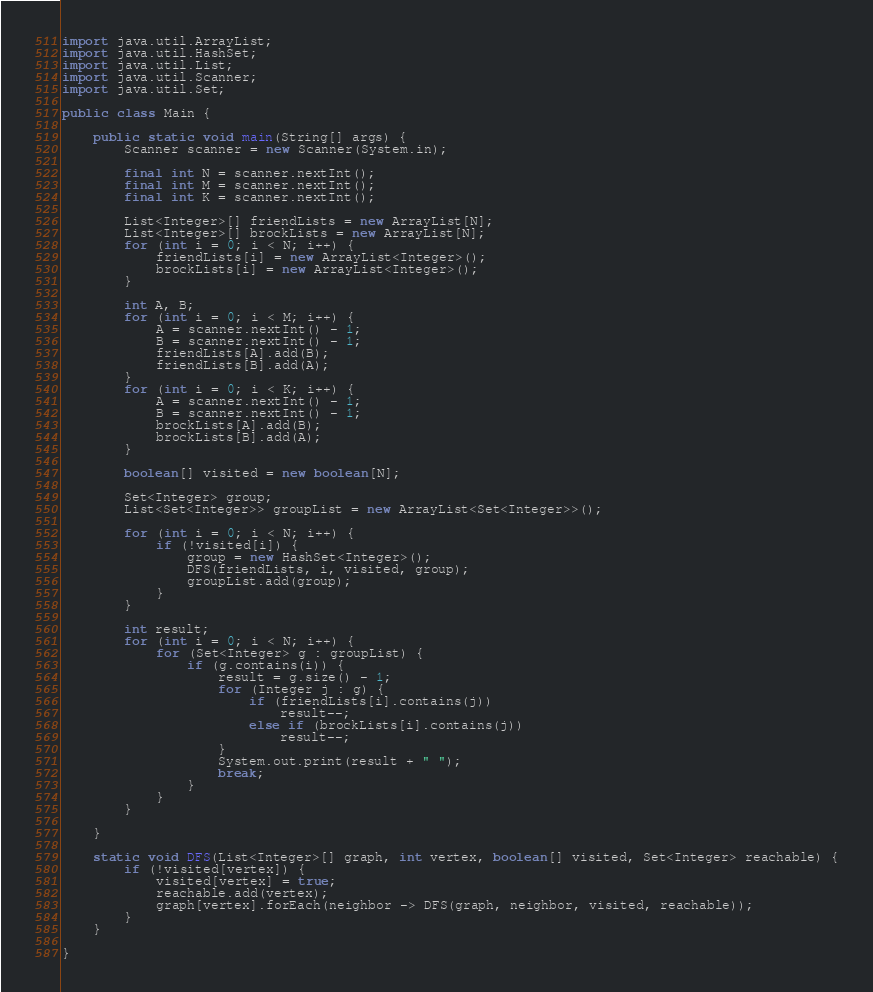<code> <loc_0><loc_0><loc_500><loc_500><_Java_>import java.util.ArrayList;
import java.util.HashSet;
import java.util.List;
import java.util.Scanner;
import java.util.Set;

public class Main {

	public static void main(String[] args) {
		Scanner scanner = new Scanner(System.in);

		final int N = scanner.nextInt();
		final int M = scanner.nextInt();
		final int K = scanner.nextInt();

		List<Integer>[] friendLists = new ArrayList[N];
		List<Integer>[] brockLists = new ArrayList[N];
		for (int i = 0; i < N; i++) {
			friendLists[i] = new ArrayList<Integer>();
			brockLists[i] = new ArrayList<Integer>();
		}

		int A, B;
		for (int i = 0; i < M; i++) {
			A = scanner.nextInt() - 1;
			B = scanner.nextInt() - 1;
			friendLists[A].add(B);
			friendLists[B].add(A);
		}
		for (int i = 0; i < K; i++) {
			A = scanner.nextInt() - 1;
			B = scanner.nextInt() - 1;
			brockLists[A].add(B);
			brockLists[B].add(A);
		}

		boolean[] visited = new boolean[N];

		Set<Integer> group;
		List<Set<Integer>> groupList = new ArrayList<Set<Integer>>();

		for (int i = 0; i < N; i++) {
			if (!visited[i]) {
				group = new HashSet<Integer>();
				DFS(friendLists, i, visited, group);
				groupList.add(group);
			}
		}

		int result;
		for (int i = 0; i < N; i++) {
			for (Set<Integer> g : groupList) {
				if (g.contains(i)) {
					result = g.size() - 1;
					for (Integer j : g) {
						if (friendLists[i].contains(j))
							result--;
						else if (brockLists[i].contains(j))
							result--;
					}
					System.out.print(result + " ");
					break;
				}
			}
		}

	}

	static void DFS(List<Integer>[] graph, int vertex, boolean[] visited, Set<Integer> reachable) {
		if (!visited[vertex]) {
			visited[vertex] = true;
			reachable.add(vertex);
			graph[vertex].forEach(neighbor -> DFS(graph, neighbor, visited, reachable));
		}
	}

}
</code> 